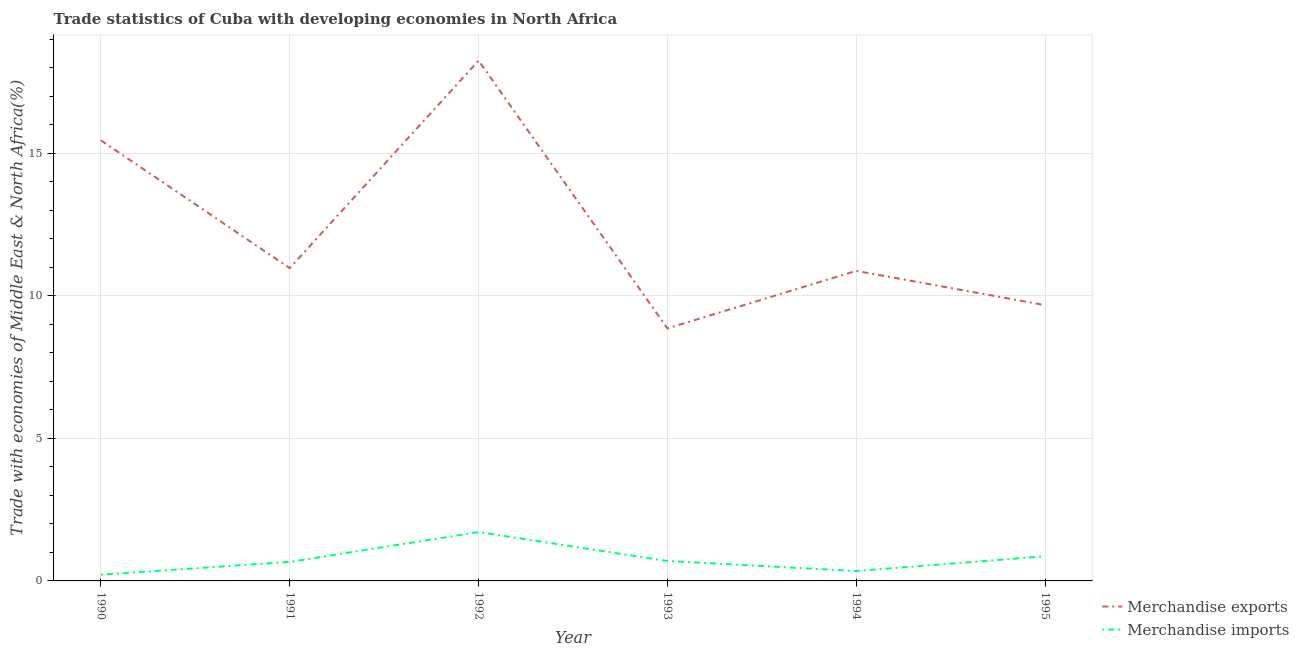Does the line corresponding to merchandise exports intersect with the line corresponding to merchandise imports?
Make the answer very short. No. Is the number of lines equal to the number of legend labels?
Ensure brevity in your answer.  Yes. What is the merchandise exports in 1993?
Provide a succinct answer. 8.86. Across all years, what is the maximum merchandise imports?
Offer a very short reply. 1.71. Across all years, what is the minimum merchandise exports?
Provide a short and direct response. 8.86. In which year was the merchandise exports minimum?
Make the answer very short. 1993. What is the total merchandise imports in the graph?
Offer a very short reply. 4.51. What is the difference between the merchandise exports in 1990 and that in 1995?
Offer a very short reply. 5.78. What is the difference between the merchandise exports in 1993 and the merchandise imports in 1992?
Your response must be concise. 7.15. What is the average merchandise imports per year?
Offer a very short reply. 0.75. In the year 1994, what is the difference between the merchandise exports and merchandise imports?
Provide a succinct answer. 10.53. In how many years, is the merchandise exports greater than 11 %?
Keep it short and to the point. 2. What is the ratio of the merchandise imports in 1991 to that in 1994?
Your response must be concise. 1.92. Is the difference between the merchandise imports in 1990 and 1995 greater than the difference between the merchandise exports in 1990 and 1995?
Provide a succinct answer. No. What is the difference between the highest and the second highest merchandise imports?
Keep it short and to the point. 0.85. What is the difference between the highest and the lowest merchandise imports?
Your answer should be compact. 1.49. Does the merchandise imports monotonically increase over the years?
Your response must be concise. No. Is the merchandise imports strictly greater than the merchandise exports over the years?
Keep it short and to the point. No. How many lines are there?
Provide a short and direct response. 2. How many years are there in the graph?
Your response must be concise. 6. Are the values on the major ticks of Y-axis written in scientific E-notation?
Your answer should be very brief. No. Does the graph contain any zero values?
Your response must be concise. No. Where does the legend appear in the graph?
Provide a succinct answer. Bottom right. How many legend labels are there?
Offer a terse response. 2. How are the legend labels stacked?
Your answer should be very brief. Vertical. What is the title of the graph?
Offer a very short reply. Trade statistics of Cuba with developing economies in North Africa. What is the label or title of the Y-axis?
Your response must be concise. Trade with economies of Middle East & North Africa(%). What is the Trade with economies of Middle East & North Africa(%) in Merchandise exports in 1990?
Provide a succinct answer. 15.46. What is the Trade with economies of Middle East & North Africa(%) in Merchandise imports in 1990?
Provide a succinct answer. 0.22. What is the Trade with economies of Middle East & North Africa(%) of Merchandise exports in 1991?
Make the answer very short. 10.97. What is the Trade with economies of Middle East & North Africa(%) in Merchandise imports in 1991?
Your answer should be very brief. 0.67. What is the Trade with economies of Middle East & North Africa(%) in Merchandise exports in 1992?
Ensure brevity in your answer.  18.26. What is the Trade with economies of Middle East & North Africa(%) of Merchandise imports in 1992?
Provide a short and direct response. 1.71. What is the Trade with economies of Middle East & North Africa(%) of Merchandise exports in 1993?
Your answer should be very brief. 8.86. What is the Trade with economies of Middle East & North Africa(%) in Merchandise imports in 1993?
Keep it short and to the point. 0.7. What is the Trade with economies of Middle East & North Africa(%) in Merchandise exports in 1994?
Offer a very short reply. 10.88. What is the Trade with economies of Middle East & North Africa(%) in Merchandise imports in 1994?
Offer a very short reply. 0.35. What is the Trade with economies of Middle East & North Africa(%) of Merchandise exports in 1995?
Make the answer very short. 9.68. What is the Trade with economies of Middle East & North Africa(%) in Merchandise imports in 1995?
Your response must be concise. 0.86. Across all years, what is the maximum Trade with economies of Middle East & North Africa(%) of Merchandise exports?
Keep it short and to the point. 18.26. Across all years, what is the maximum Trade with economies of Middle East & North Africa(%) in Merchandise imports?
Provide a short and direct response. 1.71. Across all years, what is the minimum Trade with economies of Middle East & North Africa(%) in Merchandise exports?
Ensure brevity in your answer.  8.86. Across all years, what is the minimum Trade with economies of Middle East & North Africa(%) of Merchandise imports?
Provide a short and direct response. 0.22. What is the total Trade with economies of Middle East & North Africa(%) of Merchandise exports in the graph?
Provide a short and direct response. 74.11. What is the total Trade with economies of Middle East & North Africa(%) in Merchandise imports in the graph?
Make the answer very short. 4.51. What is the difference between the Trade with economies of Middle East & North Africa(%) of Merchandise exports in 1990 and that in 1991?
Offer a very short reply. 4.48. What is the difference between the Trade with economies of Middle East & North Africa(%) of Merchandise imports in 1990 and that in 1991?
Your answer should be compact. -0.45. What is the difference between the Trade with economies of Middle East & North Africa(%) of Merchandise imports in 1990 and that in 1992?
Ensure brevity in your answer.  -1.49. What is the difference between the Trade with economies of Middle East & North Africa(%) of Merchandise exports in 1990 and that in 1993?
Keep it short and to the point. 6.6. What is the difference between the Trade with economies of Middle East & North Africa(%) in Merchandise imports in 1990 and that in 1993?
Provide a short and direct response. -0.48. What is the difference between the Trade with economies of Middle East & North Africa(%) in Merchandise exports in 1990 and that in 1994?
Make the answer very short. 4.58. What is the difference between the Trade with economies of Middle East & North Africa(%) in Merchandise imports in 1990 and that in 1994?
Make the answer very short. -0.13. What is the difference between the Trade with economies of Middle East & North Africa(%) of Merchandise exports in 1990 and that in 1995?
Give a very brief answer. 5.78. What is the difference between the Trade with economies of Middle East & North Africa(%) of Merchandise imports in 1990 and that in 1995?
Provide a succinct answer. -0.64. What is the difference between the Trade with economies of Middle East & North Africa(%) in Merchandise exports in 1991 and that in 1992?
Provide a short and direct response. -7.28. What is the difference between the Trade with economies of Middle East & North Africa(%) of Merchandise imports in 1991 and that in 1992?
Offer a very short reply. -1.05. What is the difference between the Trade with economies of Middle East & North Africa(%) of Merchandise exports in 1991 and that in 1993?
Ensure brevity in your answer.  2.11. What is the difference between the Trade with economies of Middle East & North Africa(%) of Merchandise imports in 1991 and that in 1993?
Your response must be concise. -0.03. What is the difference between the Trade with economies of Middle East & North Africa(%) of Merchandise exports in 1991 and that in 1994?
Make the answer very short. 0.1. What is the difference between the Trade with economies of Middle East & North Africa(%) of Merchandise imports in 1991 and that in 1994?
Provide a succinct answer. 0.32. What is the difference between the Trade with economies of Middle East & North Africa(%) of Merchandise exports in 1991 and that in 1995?
Your answer should be compact. 1.3. What is the difference between the Trade with economies of Middle East & North Africa(%) in Merchandise imports in 1991 and that in 1995?
Offer a very short reply. -0.2. What is the difference between the Trade with economies of Middle East & North Africa(%) of Merchandise exports in 1992 and that in 1993?
Provide a succinct answer. 9.4. What is the difference between the Trade with economies of Middle East & North Africa(%) in Merchandise imports in 1992 and that in 1993?
Give a very brief answer. 1.01. What is the difference between the Trade with economies of Middle East & North Africa(%) of Merchandise exports in 1992 and that in 1994?
Offer a very short reply. 7.38. What is the difference between the Trade with economies of Middle East & North Africa(%) of Merchandise imports in 1992 and that in 1994?
Keep it short and to the point. 1.37. What is the difference between the Trade with economies of Middle East & North Africa(%) of Merchandise exports in 1992 and that in 1995?
Keep it short and to the point. 8.58. What is the difference between the Trade with economies of Middle East & North Africa(%) in Merchandise imports in 1992 and that in 1995?
Your answer should be very brief. 0.85. What is the difference between the Trade with economies of Middle East & North Africa(%) of Merchandise exports in 1993 and that in 1994?
Offer a terse response. -2.02. What is the difference between the Trade with economies of Middle East & North Africa(%) in Merchandise imports in 1993 and that in 1994?
Your answer should be very brief. 0.35. What is the difference between the Trade with economies of Middle East & North Africa(%) in Merchandise exports in 1993 and that in 1995?
Your answer should be compact. -0.82. What is the difference between the Trade with economies of Middle East & North Africa(%) in Merchandise imports in 1993 and that in 1995?
Your response must be concise. -0.17. What is the difference between the Trade with economies of Middle East & North Africa(%) of Merchandise exports in 1994 and that in 1995?
Provide a succinct answer. 1.2. What is the difference between the Trade with economies of Middle East & North Africa(%) of Merchandise imports in 1994 and that in 1995?
Provide a succinct answer. -0.52. What is the difference between the Trade with economies of Middle East & North Africa(%) of Merchandise exports in 1990 and the Trade with economies of Middle East & North Africa(%) of Merchandise imports in 1991?
Make the answer very short. 14.79. What is the difference between the Trade with economies of Middle East & North Africa(%) of Merchandise exports in 1990 and the Trade with economies of Middle East & North Africa(%) of Merchandise imports in 1992?
Offer a terse response. 13.74. What is the difference between the Trade with economies of Middle East & North Africa(%) of Merchandise exports in 1990 and the Trade with economies of Middle East & North Africa(%) of Merchandise imports in 1993?
Make the answer very short. 14.76. What is the difference between the Trade with economies of Middle East & North Africa(%) of Merchandise exports in 1990 and the Trade with economies of Middle East & North Africa(%) of Merchandise imports in 1994?
Offer a very short reply. 15.11. What is the difference between the Trade with economies of Middle East & North Africa(%) of Merchandise exports in 1990 and the Trade with economies of Middle East & North Africa(%) of Merchandise imports in 1995?
Provide a short and direct response. 14.59. What is the difference between the Trade with economies of Middle East & North Africa(%) of Merchandise exports in 1991 and the Trade with economies of Middle East & North Africa(%) of Merchandise imports in 1992?
Your answer should be compact. 9.26. What is the difference between the Trade with economies of Middle East & North Africa(%) in Merchandise exports in 1991 and the Trade with economies of Middle East & North Africa(%) in Merchandise imports in 1993?
Offer a very short reply. 10.28. What is the difference between the Trade with economies of Middle East & North Africa(%) of Merchandise exports in 1991 and the Trade with economies of Middle East & North Africa(%) of Merchandise imports in 1994?
Your response must be concise. 10.63. What is the difference between the Trade with economies of Middle East & North Africa(%) of Merchandise exports in 1991 and the Trade with economies of Middle East & North Africa(%) of Merchandise imports in 1995?
Make the answer very short. 10.11. What is the difference between the Trade with economies of Middle East & North Africa(%) in Merchandise exports in 1992 and the Trade with economies of Middle East & North Africa(%) in Merchandise imports in 1993?
Offer a very short reply. 17.56. What is the difference between the Trade with economies of Middle East & North Africa(%) in Merchandise exports in 1992 and the Trade with economies of Middle East & North Africa(%) in Merchandise imports in 1994?
Offer a very short reply. 17.91. What is the difference between the Trade with economies of Middle East & North Africa(%) of Merchandise exports in 1992 and the Trade with economies of Middle East & North Africa(%) of Merchandise imports in 1995?
Your answer should be very brief. 17.39. What is the difference between the Trade with economies of Middle East & North Africa(%) in Merchandise exports in 1993 and the Trade with economies of Middle East & North Africa(%) in Merchandise imports in 1994?
Ensure brevity in your answer.  8.51. What is the difference between the Trade with economies of Middle East & North Africa(%) in Merchandise exports in 1993 and the Trade with economies of Middle East & North Africa(%) in Merchandise imports in 1995?
Your answer should be compact. 8. What is the difference between the Trade with economies of Middle East & North Africa(%) in Merchandise exports in 1994 and the Trade with economies of Middle East & North Africa(%) in Merchandise imports in 1995?
Your answer should be very brief. 10.01. What is the average Trade with economies of Middle East & North Africa(%) in Merchandise exports per year?
Offer a terse response. 12.35. What is the average Trade with economies of Middle East & North Africa(%) in Merchandise imports per year?
Your answer should be compact. 0.75. In the year 1990, what is the difference between the Trade with economies of Middle East & North Africa(%) in Merchandise exports and Trade with economies of Middle East & North Africa(%) in Merchandise imports?
Make the answer very short. 15.24. In the year 1991, what is the difference between the Trade with economies of Middle East & North Africa(%) in Merchandise exports and Trade with economies of Middle East & North Africa(%) in Merchandise imports?
Make the answer very short. 10.31. In the year 1992, what is the difference between the Trade with economies of Middle East & North Africa(%) in Merchandise exports and Trade with economies of Middle East & North Africa(%) in Merchandise imports?
Give a very brief answer. 16.54. In the year 1993, what is the difference between the Trade with economies of Middle East & North Africa(%) of Merchandise exports and Trade with economies of Middle East & North Africa(%) of Merchandise imports?
Provide a succinct answer. 8.16. In the year 1994, what is the difference between the Trade with economies of Middle East & North Africa(%) of Merchandise exports and Trade with economies of Middle East & North Africa(%) of Merchandise imports?
Offer a terse response. 10.53. In the year 1995, what is the difference between the Trade with economies of Middle East & North Africa(%) of Merchandise exports and Trade with economies of Middle East & North Africa(%) of Merchandise imports?
Offer a terse response. 8.81. What is the ratio of the Trade with economies of Middle East & North Africa(%) in Merchandise exports in 1990 to that in 1991?
Your response must be concise. 1.41. What is the ratio of the Trade with economies of Middle East & North Africa(%) of Merchandise imports in 1990 to that in 1991?
Provide a short and direct response. 0.33. What is the ratio of the Trade with economies of Middle East & North Africa(%) in Merchandise exports in 1990 to that in 1992?
Ensure brevity in your answer.  0.85. What is the ratio of the Trade with economies of Middle East & North Africa(%) of Merchandise imports in 1990 to that in 1992?
Provide a short and direct response. 0.13. What is the ratio of the Trade with economies of Middle East & North Africa(%) in Merchandise exports in 1990 to that in 1993?
Make the answer very short. 1.74. What is the ratio of the Trade with economies of Middle East & North Africa(%) in Merchandise imports in 1990 to that in 1993?
Give a very brief answer. 0.31. What is the ratio of the Trade with economies of Middle East & North Africa(%) in Merchandise exports in 1990 to that in 1994?
Offer a very short reply. 1.42. What is the ratio of the Trade with economies of Middle East & North Africa(%) in Merchandise imports in 1990 to that in 1994?
Keep it short and to the point. 0.63. What is the ratio of the Trade with economies of Middle East & North Africa(%) in Merchandise exports in 1990 to that in 1995?
Offer a terse response. 1.6. What is the ratio of the Trade with economies of Middle East & North Africa(%) in Merchandise imports in 1990 to that in 1995?
Keep it short and to the point. 0.25. What is the ratio of the Trade with economies of Middle East & North Africa(%) in Merchandise exports in 1991 to that in 1992?
Give a very brief answer. 0.6. What is the ratio of the Trade with economies of Middle East & North Africa(%) in Merchandise imports in 1991 to that in 1992?
Make the answer very short. 0.39. What is the ratio of the Trade with economies of Middle East & North Africa(%) in Merchandise exports in 1991 to that in 1993?
Keep it short and to the point. 1.24. What is the ratio of the Trade with economies of Middle East & North Africa(%) of Merchandise imports in 1991 to that in 1993?
Your response must be concise. 0.95. What is the ratio of the Trade with economies of Middle East & North Africa(%) of Merchandise exports in 1991 to that in 1994?
Give a very brief answer. 1.01. What is the ratio of the Trade with economies of Middle East & North Africa(%) in Merchandise imports in 1991 to that in 1994?
Your answer should be compact. 1.92. What is the ratio of the Trade with economies of Middle East & North Africa(%) in Merchandise exports in 1991 to that in 1995?
Your answer should be very brief. 1.13. What is the ratio of the Trade with economies of Middle East & North Africa(%) in Merchandise imports in 1991 to that in 1995?
Your response must be concise. 0.77. What is the ratio of the Trade with economies of Middle East & North Africa(%) in Merchandise exports in 1992 to that in 1993?
Ensure brevity in your answer.  2.06. What is the ratio of the Trade with economies of Middle East & North Africa(%) in Merchandise imports in 1992 to that in 1993?
Offer a terse response. 2.45. What is the ratio of the Trade with economies of Middle East & North Africa(%) of Merchandise exports in 1992 to that in 1994?
Your answer should be very brief. 1.68. What is the ratio of the Trade with economies of Middle East & North Africa(%) of Merchandise imports in 1992 to that in 1994?
Make the answer very short. 4.93. What is the ratio of the Trade with economies of Middle East & North Africa(%) in Merchandise exports in 1992 to that in 1995?
Your response must be concise. 1.89. What is the ratio of the Trade with economies of Middle East & North Africa(%) of Merchandise imports in 1992 to that in 1995?
Your answer should be very brief. 1.98. What is the ratio of the Trade with economies of Middle East & North Africa(%) in Merchandise exports in 1993 to that in 1994?
Provide a succinct answer. 0.81. What is the ratio of the Trade with economies of Middle East & North Africa(%) of Merchandise imports in 1993 to that in 1994?
Ensure brevity in your answer.  2.01. What is the ratio of the Trade with economies of Middle East & North Africa(%) of Merchandise exports in 1993 to that in 1995?
Offer a very short reply. 0.92. What is the ratio of the Trade with economies of Middle East & North Africa(%) of Merchandise imports in 1993 to that in 1995?
Your answer should be compact. 0.81. What is the ratio of the Trade with economies of Middle East & North Africa(%) in Merchandise exports in 1994 to that in 1995?
Your answer should be compact. 1.12. What is the ratio of the Trade with economies of Middle East & North Africa(%) of Merchandise imports in 1994 to that in 1995?
Provide a short and direct response. 0.4. What is the difference between the highest and the second highest Trade with economies of Middle East & North Africa(%) in Merchandise exports?
Provide a succinct answer. 2.8. What is the difference between the highest and the second highest Trade with economies of Middle East & North Africa(%) in Merchandise imports?
Offer a very short reply. 0.85. What is the difference between the highest and the lowest Trade with economies of Middle East & North Africa(%) in Merchandise exports?
Keep it short and to the point. 9.4. What is the difference between the highest and the lowest Trade with economies of Middle East & North Africa(%) of Merchandise imports?
Offer a very short reply. 1.49. 